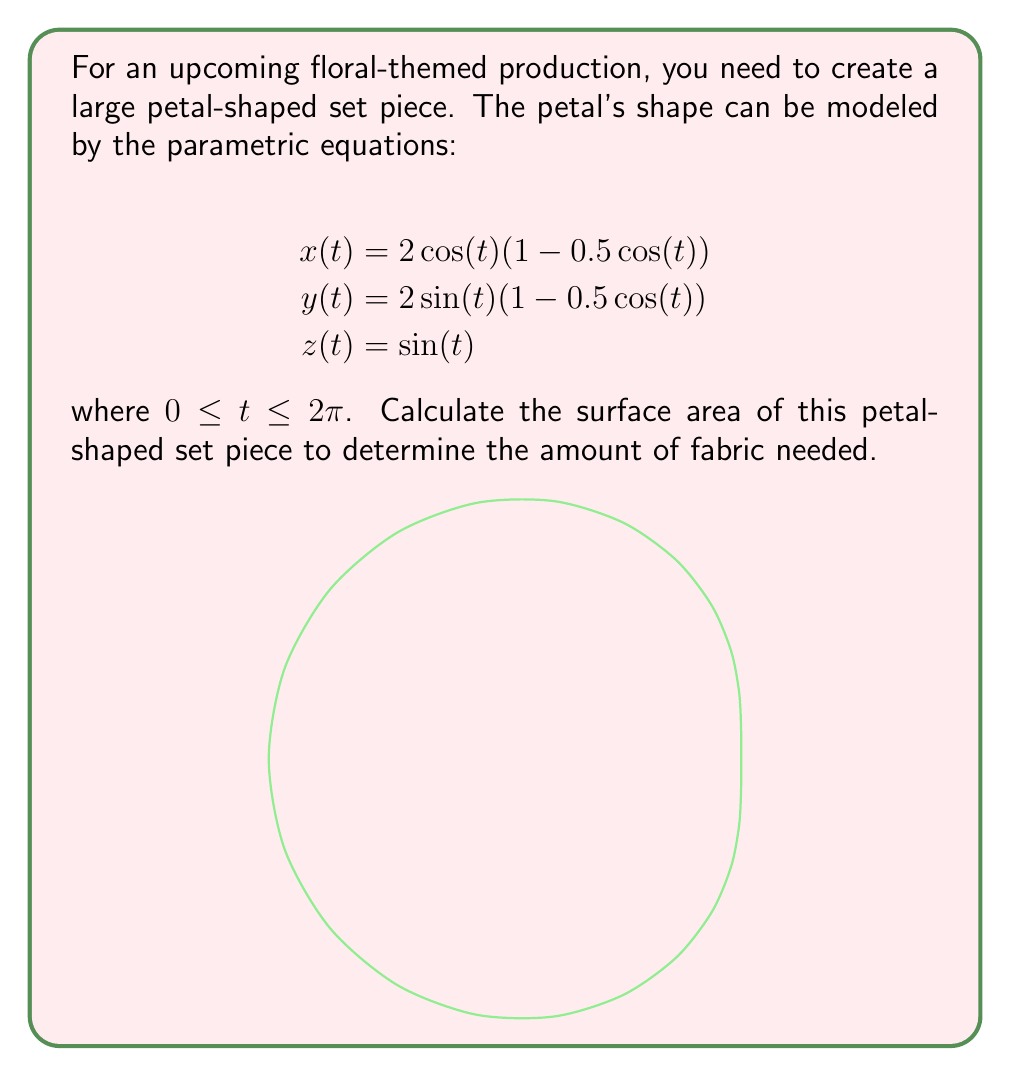Can you solve this math problem? To find the surface area, we need to use the surface area formula for parametric equations:

$$\text{Surface Area} = \int_a^b \sqrt{(\frac{dx}{dt})^2 + (\frac{dy}{dt})^2 + (\frac{dz}{dt})^2} dt$$

Step 1: Calculate the derivatives
$$\frac{dx}{dt} = -2\sin(t)(1-0.5\cos(t)) + \cos(t)\sin(t)$$
$$\frac{dy}{dt} = 2\cos(t)(1-0.5\cos(t)) + \sin(t)\sin(t)$$
$$\frac{dz}{dt} = \cos(t)$$

Step 2: Square each derivative and add them
$$(\frac{dx}{dt})^2 + (\frac{dy}{dt})^2 + (\frac{dz}{dt})^2 = $$
$$(4\sin^2(t)(1-\cos(t)+0.25\cos^2(t)) + 4\cos^2(t)(1-\cos(t)+0.25\cos^2(t)) + \cos^2(t))$$

Step 3: Simplify
$$= 4(1-\cos(t)+0.25\cos^2(t))(\sin^2(t)+\cos^2(t)) + \cos^2(t)$$
$$= 4(1-\cos(t)+0.25\cos^2(t)) + \cos^2(t)$$
$$= 4 - 4\cos(t) + \cos^2(t) + \cos^2(t)$$
$$= 4 - 4\cos(t) + 2\cos^2(t)$$

Step 4: Take the square root and integrate
$$\text{Surface Area} = \int_0^{2\pi} \sqrt{4 - 4\cos(t) + 2\cos^2(t)} dt$$

This integral doesn't have a simple closed form and needs to be evaluated numerically. Using numerical integration methods, we find:

$$\text{Surface Area} \approx 20.7345 \text{ square units}$$
Answer: $20.7345 \text{ square units}$ 